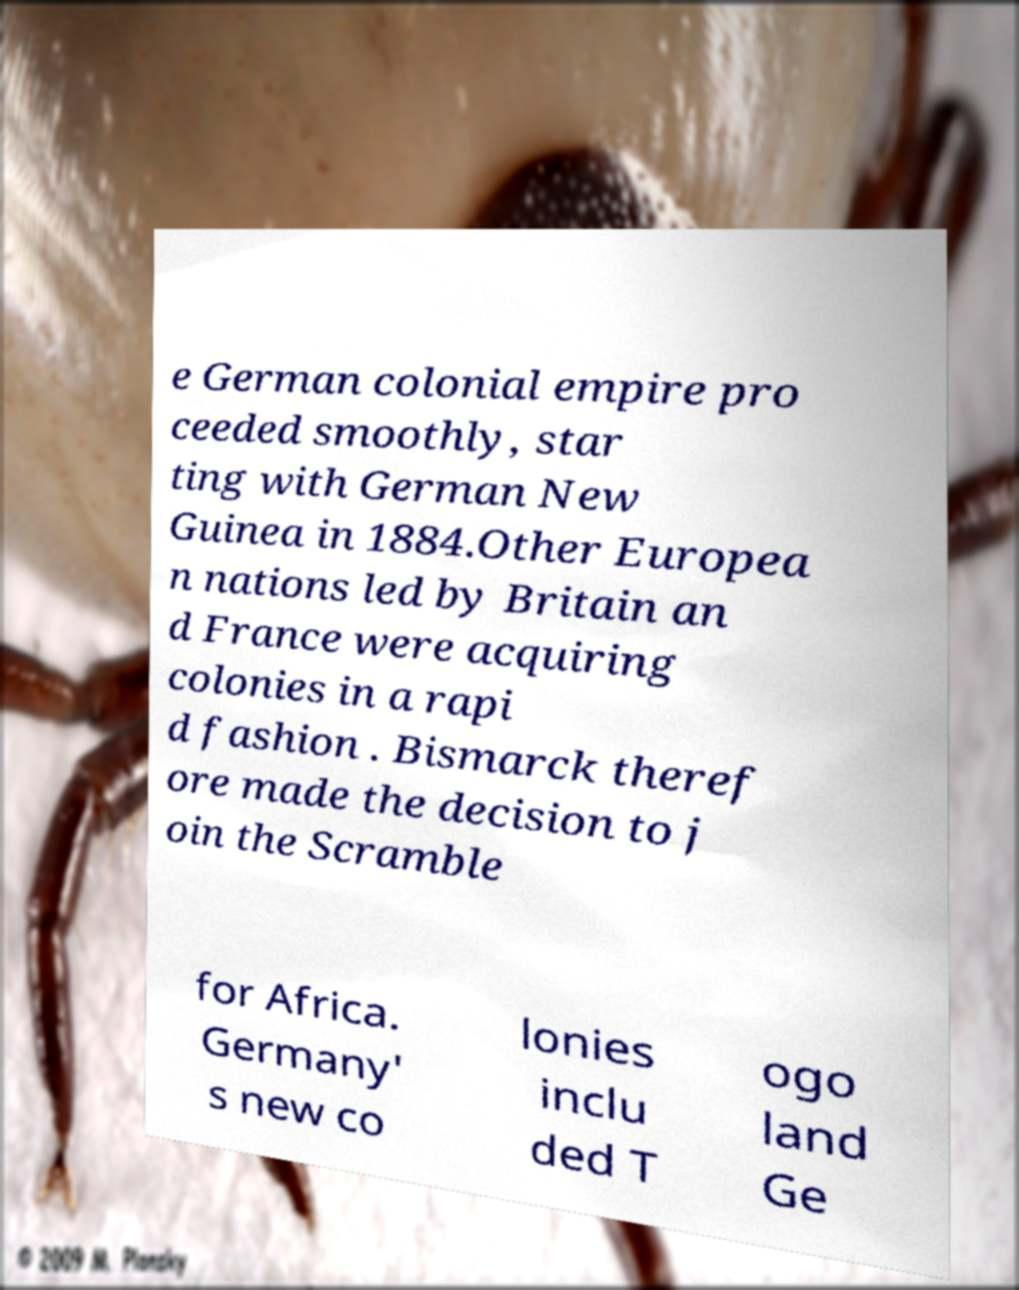Please read and relay the text visible in this image. What does it say? e German colonial empire pro ceeded smoothly, star ting with German New Guinea in 1884.Other Europea n nations led by Britain an d France were acquiring colonies in a rapi d fashion . Bismarck theref ore made the decision to j oin the Scramble for Africa. Germany' s new co lonies inclu ded T ogo land Ge 